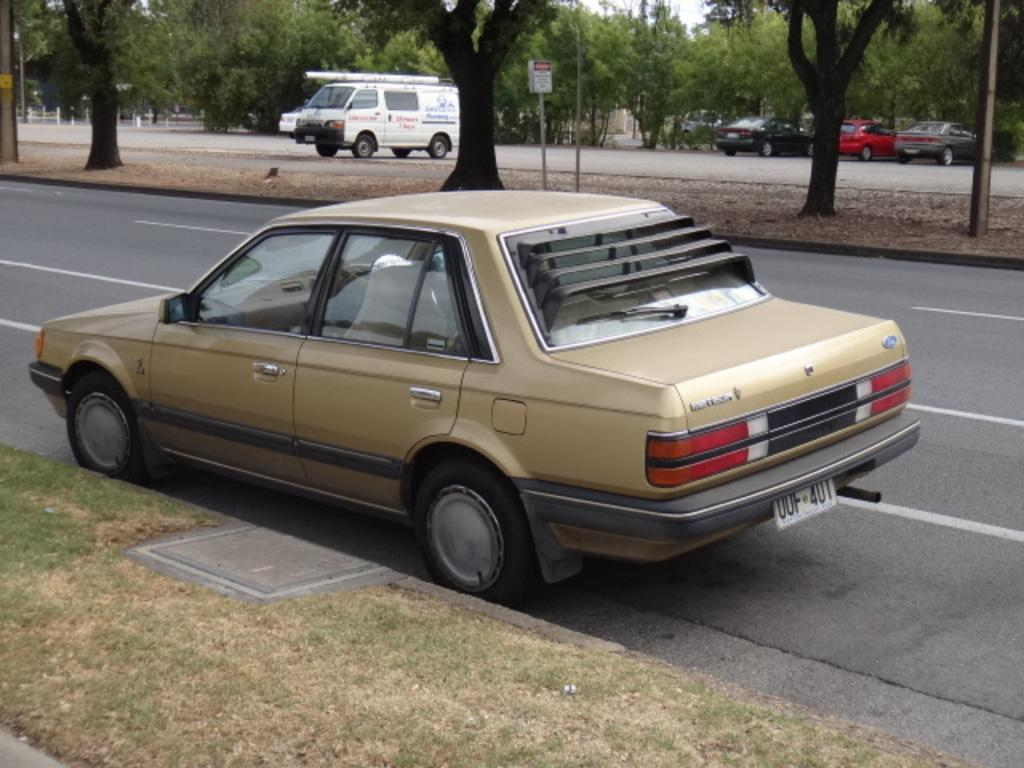What is located in the foreground of the image? There is a car in the foreground of the image. What type of natural vegetation can be seen in the image? There are trees visible in the image. What other vehicles, besides the car, can be seen in the image? There are other vehicles in the image. What type of waste can be seen scattered around the car in the image? There is no waste visible in the image; it only shows a car, trees, and other vehicles. What type of drink is being consumed by the people in the image? There are no people present in the image, so it cannot be determined if anyone is consuming a drink. 